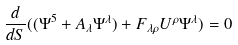<formula> <loc_0><loc_0><loc_500><loc_500>\frac { d } { d S } ( ( \Psi ^ { 5 } + A _ { \lambda } \Psi ^ { \lambda } ) + F _ { \lambda \rho } U ^ { \rho } \Psi ^ { \lambda } ) = 0</formula> 